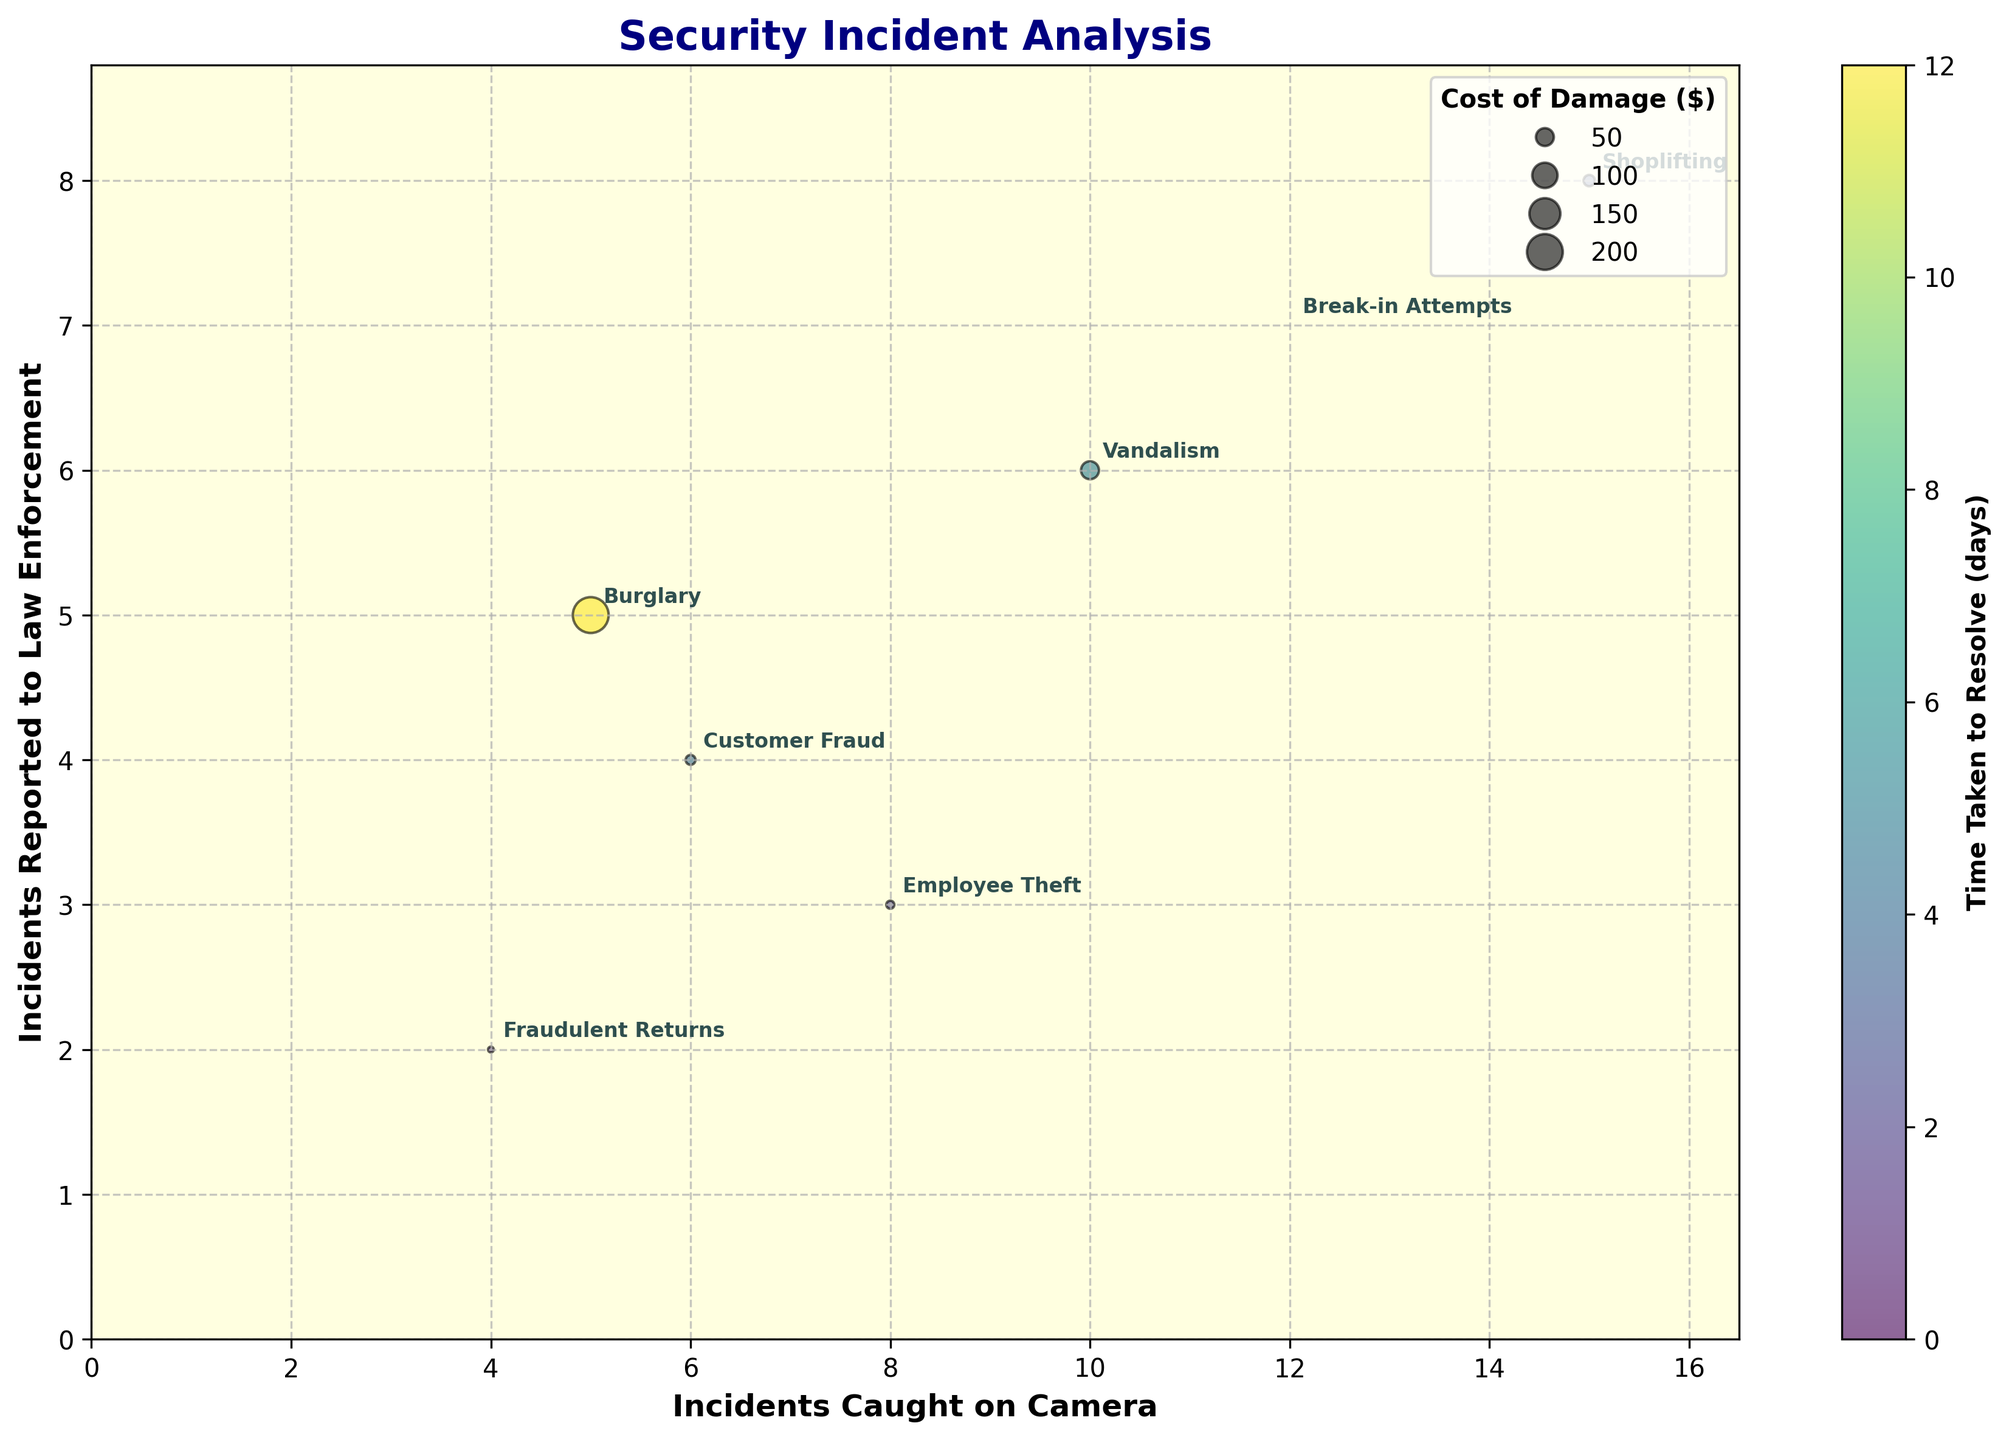What is the title of the chart? The title of the chart is usually indicated at the top of the figure. In this case, it directly states it is about security incidents.
Answer: Security Incident Analysis How many unique incident types are represented in the figure? There are bubbles for each incident type. Counting the labels next to each bubble reveals the number of unique incident types.
Answer: 7 Which incident type has the highest number of incidents caught on camera? Find the bubble with the highest x-coordinate and identify the label associated with that bubble.
Answer: Shoplifting Which two types of incidents have the same number of incidents reported to law enforcement? Look for bubbles that align vertically (same y-coordinate) and identify their labels.
Answer: Burglary and Shoplifting Which type of incident took the most time to resolve? The color bar on the side represents the time taken to resolve. Identify the bubble that corresponds to the darkest color and check its label.
Answer: Burglary What is the cost of damage for the incident type with the most incidents reported to law enforcement? Identify the bubble furthest up on the y-axis and refer to its size, as bubble size reflects the cost of damage.
Answer: Burglary ($2000) What is the average number of incidents caught on camera for incidents involving customer activities (Shoplifting, Customer Fraud, Fraudulent Returns)? Sum the x-coordinates (15+6+4) for these types and divide by the number of types, which is 3.
Answer: 8.33 How does Employee Theft compare to Vandalism in terms of incidents caught on camera and incidents reported to law enforcement? Compare the x and y coordinates of the bubbles labeled "Employee Theft" and "Vandalism." Employee Theft: Caught on Camera (8) and Reported (3). Vandalism: Caught on Camera (10) and Reported (6).
Answer: Employee Theft has fewer incidents both caught on camera and reported than Vandalism Which incident type had no cost of damage? The cost of damage is depicted by bubble size. Find the smallest bubble or any bubble with zero size and check its label.
Answer: Break-in Attempts What is the correlation between incidents reported to law enforcement and the time taken to resolve? Analyze the general trend depicted by the color gradient of bubbles as one moves up the y-axis. Darker colors (indicating more time) tend to appear higher up the y-axis.
Answer: Positive correlation 